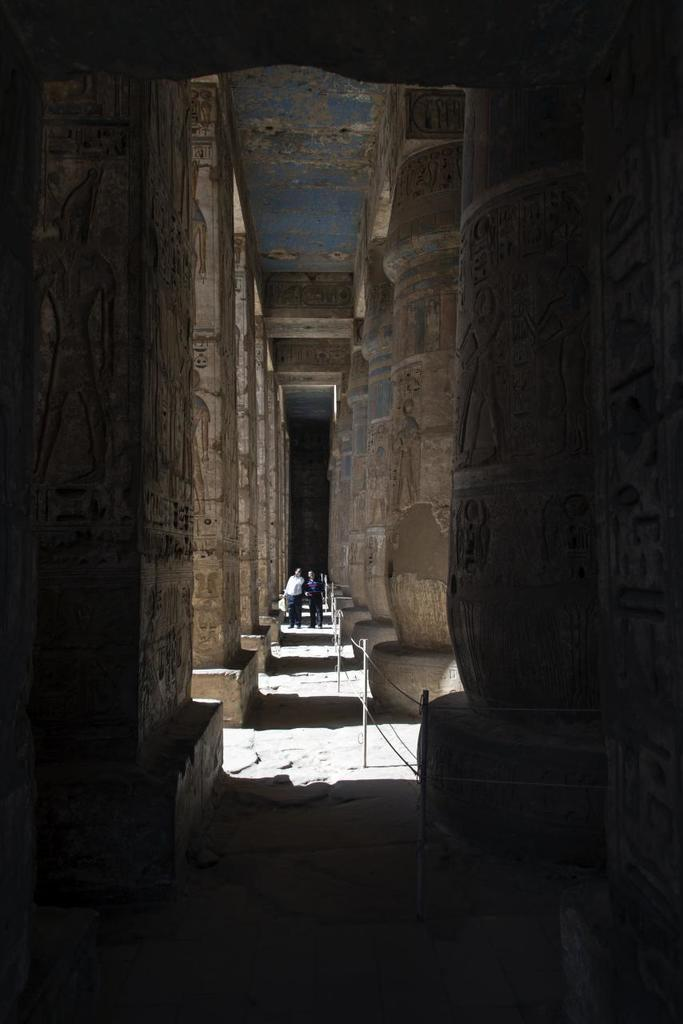What can be seen on both sides of the path in the image? There are pillars on both sides of the path in the image. What is happening on the path? There are two people standing on the path. What decorative features can be observed on the pillars? Carvings are visible on the pillars. What type of discussion is taking place between the two people on the path? There is no indication of a discussion taking place between the two people in the image. Can you see a ship in the image? There is no ship present in the image. 